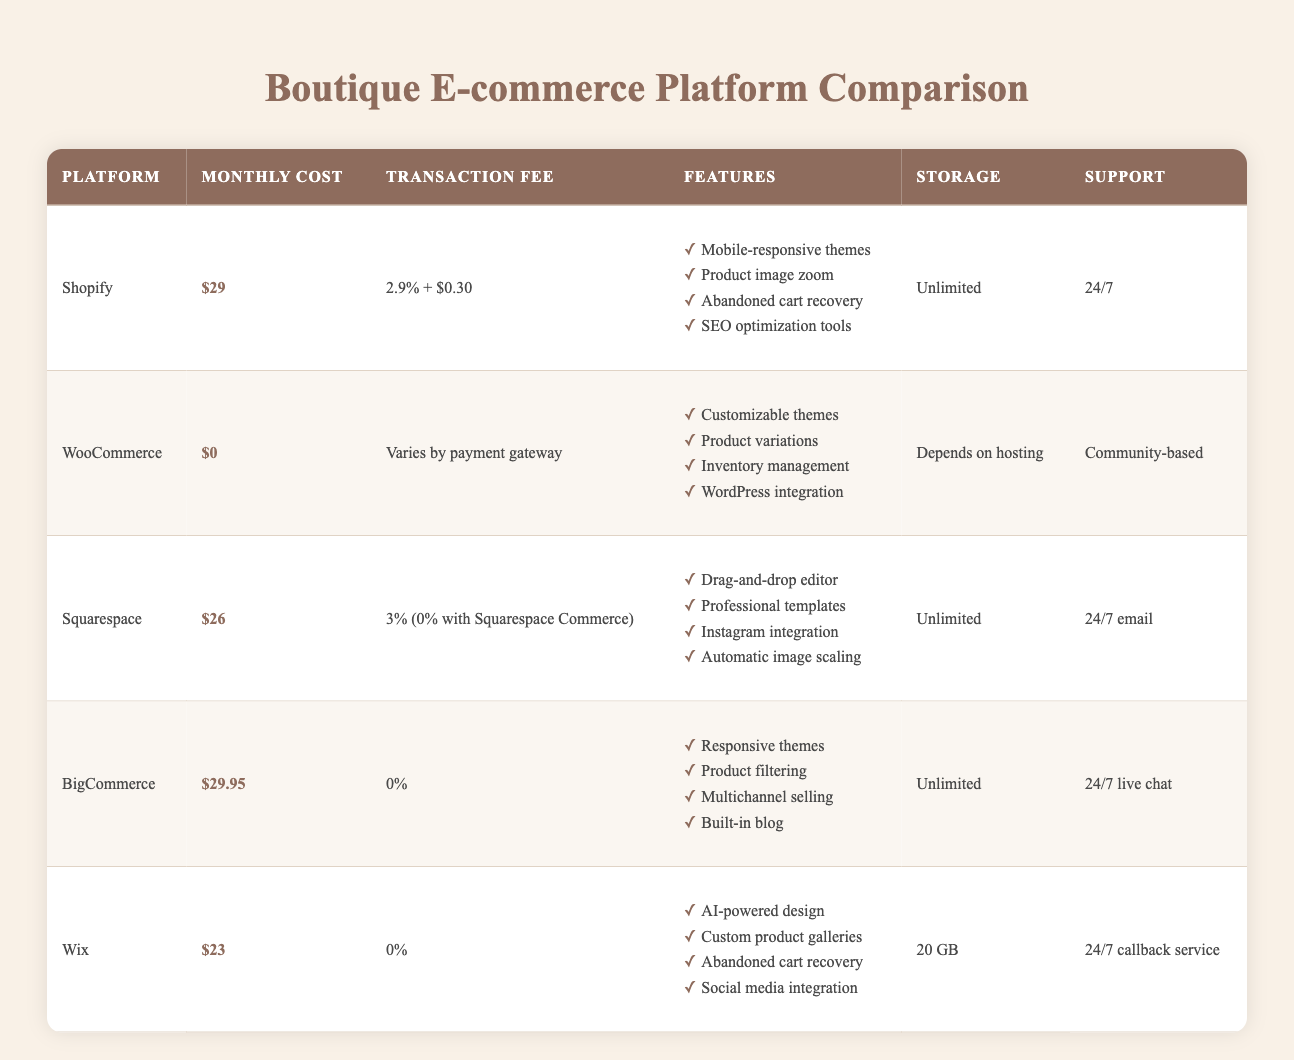What is the monthly cost of Shopify? The table lists "Shopify" under the "Platform" column. The corresponding "Monthly Cost" column shows "$29".
Answer: $29 Which platform has the highest transaction fee? The highest transaction fee can be determined from the "Transaction Fee" column. Shopify has a fee of "2.9% + $0.30", which is higher than the rest.
Answer: Shopify Which platforms offer unlimited storage? By checking the "Storage" column for the platforms, Shopify, Squarespace, and BigCommerce all indicate "Unlimited".
Answer: Shopify, Squarespace, BigCommerce What is the average monthly cost of the platforms listed? To find the average, sum the monthly costs: 29 + 0 + 26 + 29.95 + 23 = 107.95. There are 5 platforms, so dividing gives an average of 107.95/5 = 21.59.
Answer: 21.59 Is it true that WooCommerce has a monthly cost associated with it? The table states that WooCommerce has a monthly cost of "$0", indicating that it does not have an associated cost.
Answer: No Which platform has the best support option? The "Support" column shows that Shopify and Squarespace offer 24/7 support, while BigCommerce also has 24/7 live chat. The comparisons will show that these offer more immediate support options compared to community-based.
Answer: Shopify, Squarespace, BigCommerce Which platform has the lowest monthly cost? By reviewing the monthly cost column, WooCommerce is marked as having "$0", which is lower than any other platform's cost.
Answer: WooCommerce How many features does BigCommerce provide? Looking at the "Features" column for BigCommerce, there are four listed items: Responsive themes, Product filtering, Multichannel selling, and Built-in blog. Thus, it provides 4 features.
Answer: 4 